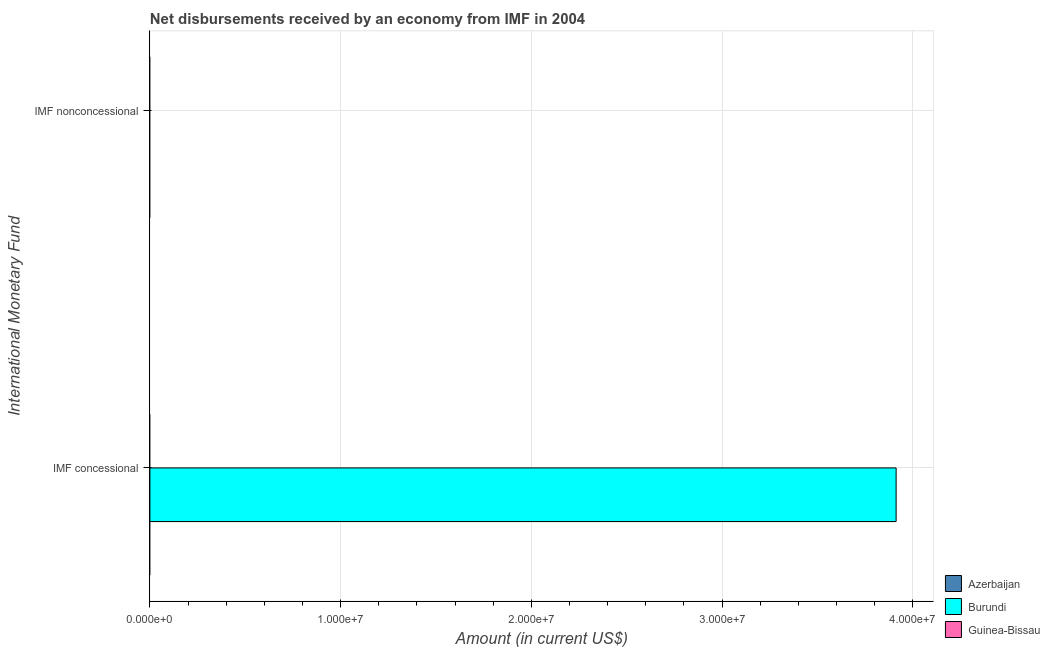How many different coloured bars are there?
Offer a very short reply. 1. Are the number of bars per tick equal to the number of legend labels?
Your answer should be very brief. No. What is the label of the 1st group of bars from the top?
Provide a short and direct response. IMF nonconcessional. Across all countries, what is the maximum net concessional disbursements from imf?
Provide a short and direct response. 3.91e+07. Across all countries, what is the minimum net non concessional disbursements from imf?
Give a very brief answer. 0. In which country was the net concessional disbursements from imf maximum?
Your response must be concise. Burundi. What is the total net non concessional disbursements from imf in the graph?
Ensure brevity in your answer.  0. What is the difference between the net concessional disbursements from imf in Azerbaijan and the net non concessional disbursements from imf in Burundi?
Offer a terse response. 0. In how many countries, is the net concessional disbursements from imf greater than the average net concessional disbursements from imf taken over all countries?
Make the answer very short. 1. Does the graph contain any zero values?
Your answer should be compact. Yes. Does the graph contain grids?
Your answer should be very brief. Yes. How many legend labels are there?
Offer a terse response. 3. How are the legend labels stacked?
Give a very brief answer. Vertical. What is the title of the graph?
Provide a short and direct response. Net disbursements received by an economy from IMF in 2004. Does "Puerto Rico" appear as one of the legend labels in the graph?
Give a very brief answer. No. What is the label or title of the X-axis?
Ensure brevity in your answer.  Amount (in current US$). What is the label or title of the Y-axis?
Keep it short and to the point. International Monetary Fund. What is the Amount (in current US$) of Burundi in IMF concessional?
Offer a very short reply. 3.91e+07. What is the Amount (in current US$) in Guinea-Bissau in IMF concessional?
Provide a short and direct response. 0. What is the Amount (in current US$) in Azerbaijan in IMF nonconcessional?
Make the answer very short. 0. What is the Amount (in current US$) in Burundi in IMF nonconcessional?
Make the answer very short. 0. Across all International Monetary Fund, what is the maximum Amount (in current US$) in Burundi?
Offer a very short reply. 3.91e+07. Across all International Monetary Fund, what is the minimum Amount (in current US$) of Burundi?
Your answer should be very brief. 0. What is the total Amount (in current US$) in Azerbaijan in the graph?
Provide a short and direct response. 0. What is the total Amount (in current US$) in Burundi in the graph?
Ensure brevity in your answer.  3.91e+07. What is the total Amount (in current US$) in Guinea-Bissau in the graph?
Make the answer very short. 0. What is the average Amount (in current US$) of Azerbaijan per International Monetary Fund?
Provide a short and direct response. 0. What is the average Amount (in current US$) of Burundi per International Monetary Fund?
Offer a very short reply. 1.96e+07. What is the difference between the highest and the lowest Amount (in current US$) in Burundi?
Your answer should be compact. 3.91e+07. 